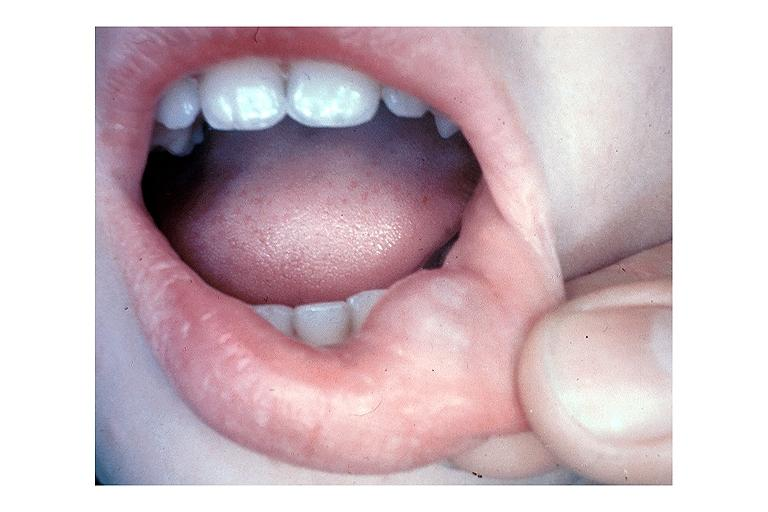s oral present?
Answer the question using a single word or phrase. Yes 